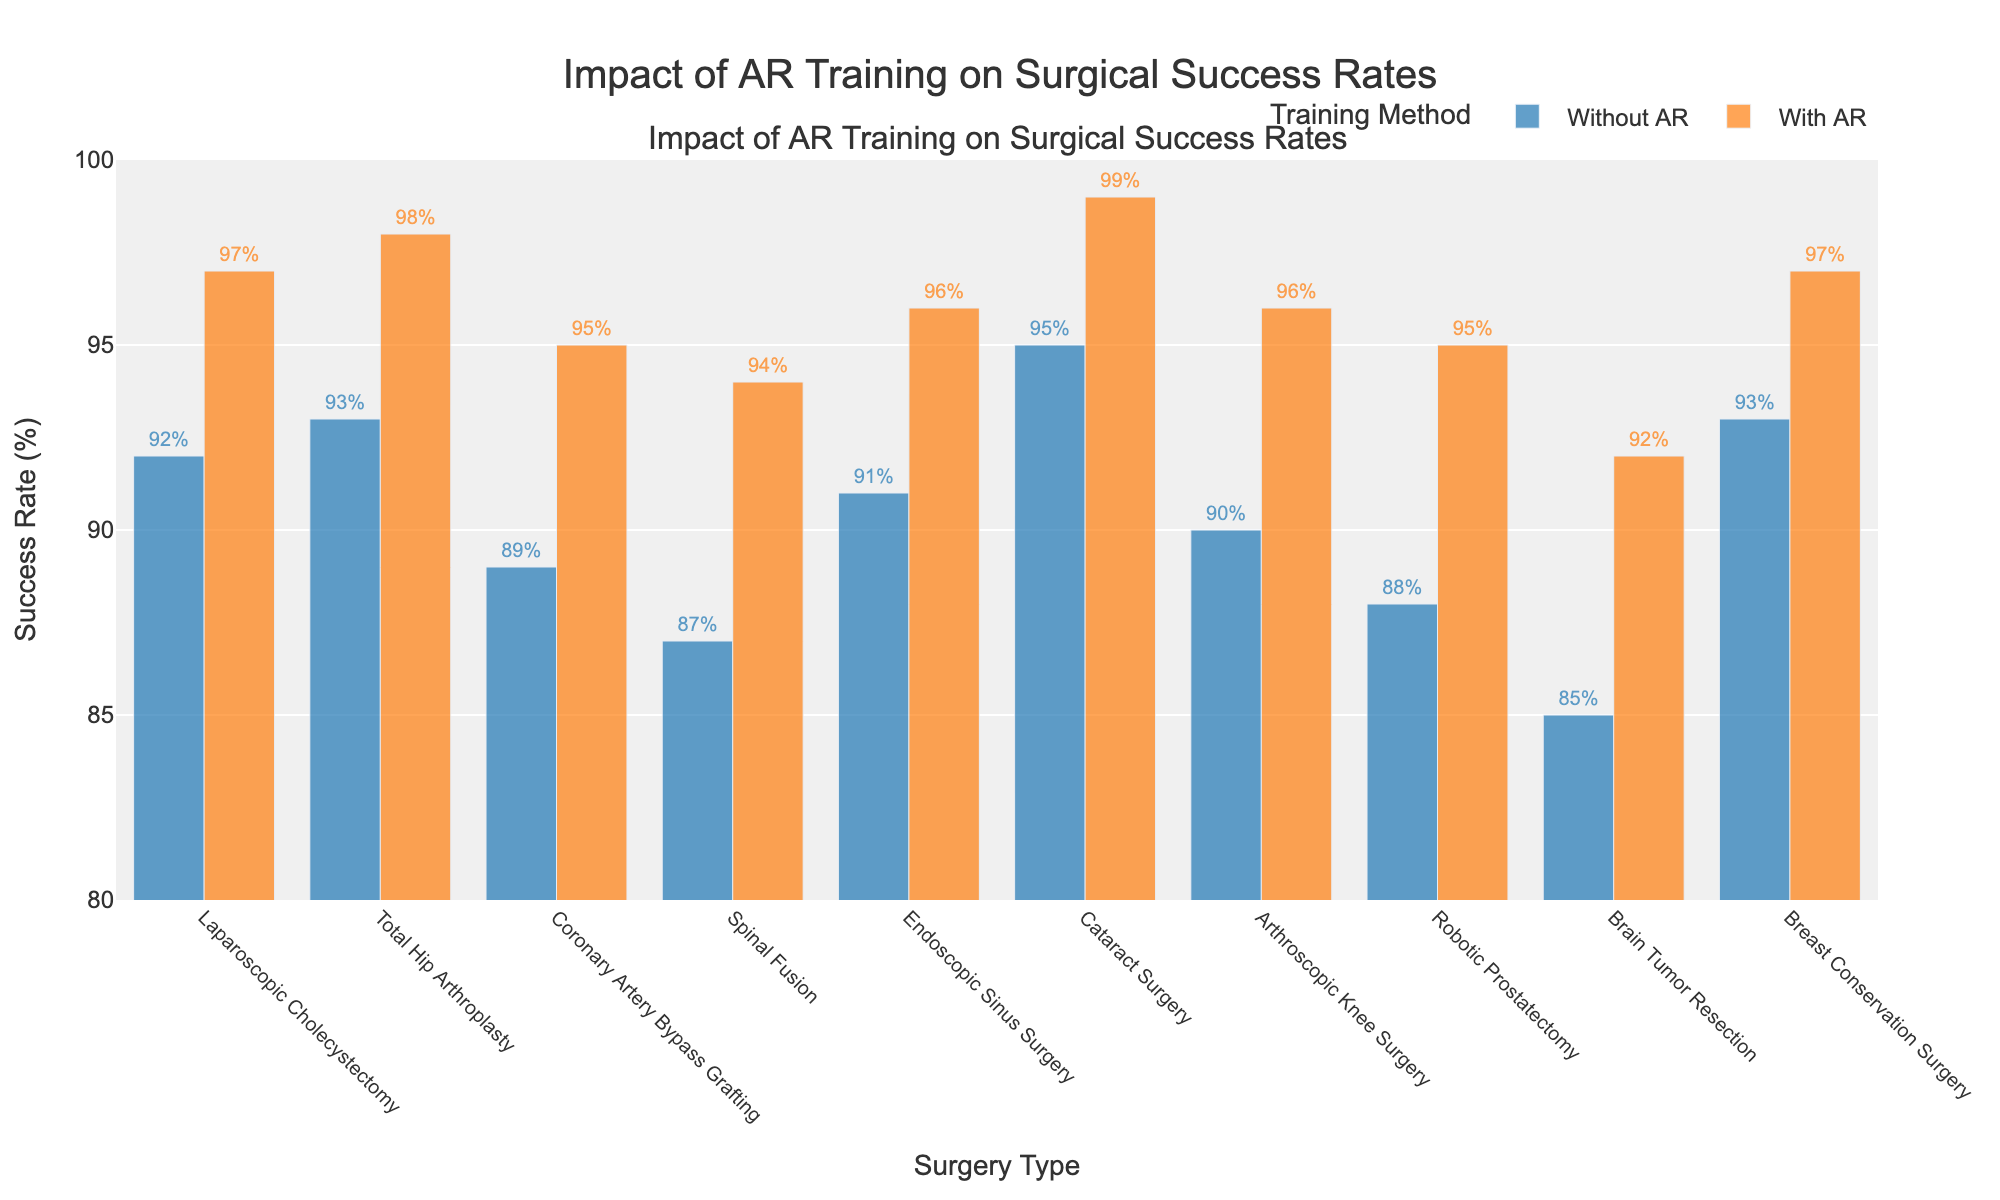What's the difference in success rates for Brain Tumor Resection with and without AR training? The success rate for Brain Tumor Resection without AR is 85%, and with AR is 92%. The difference is 92% - 85% = 7%.
Answer: 7% Which surgery type shows the highest increase in success rate with AR training compared to without? By comparing the differences in success rates for all surgery types, Cataract Surgery has the highest increase from 95% to 99%, which is an increase of 4%.
Answer: Cataract Surgery How many surgery types have a success rate of 95% or higher with AR training? By examining the success rates with AR training across all surgery types, six surgeries (Laparoscopic Cholecystectomy, Total Hip Arthroplasty, Coronary Artery Bypass Grafting, Cataract Surgery, Endoscopic Sinus Surgery, and Arthroscopic Knee Surgery) have success rates of 95% or higher.
Answer: 6 For which surgery type is the impact of AR training most noticeable in terms of percentage improvement? Calculate the percentage improvement for each surgery type by comparing the success rates with and without AR training. Brain Tumor Resection has an improvement from 85% to 92%, which is an improvement of (92-85)/85 * 100% = 8.24%.
Answer: Brain Tumor Resection Do any surgeries have the same success rate both with and without AR training? By checking the success rates with and without AR training for all surgeries, none have the same rates.
Answer: No What is the average success rate with AR training across all presented surgeries? Sum up the success rates with AR training for all surgeries (97+98+95+94+96+99+96+95+92+97) = 959 and then divide by the number of surgery types (10), 959/10 = 95.9%.
Answer: 95.9% Which surgery type benefits the least from AR training in terms of success rate increase? By comparing the differences in success rates, Total Hip Arthroplasty has the smallest increase from 93% to 98%, which is an increase of 5%.
Answer: Total Hip Arthroplasty What's the overall success rate improvement percentage across all surgeries when using AR training? Sum the success rates without and with AR training separately: 
Without AR = 898%, With AR = 959%; 
Improvement = (959 - 898) = 61%;
Percentage improvement: (61 / 898) * 100% ≈ 6.79%.
Answer: 6.79% How does the visual color coding help interpret the success rates in the graph? The two different colors (blue for without AR, orange for with AR) allow viewers to quickly distinguish between the success rates of surgeries with and without AR training at a glance.
Answer: Differentiates success rates 